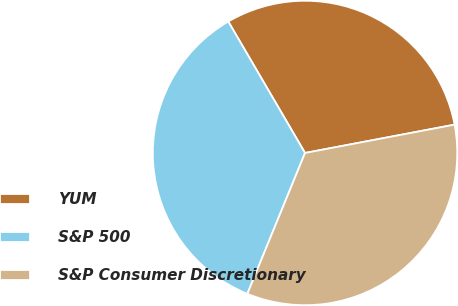Convert chart. <chart><loc_0><loc_0><loc_500><loc_500><pie_chart><fcel>YUM<fcel>S&P 500<fcel>S&P Consumer Discretionary<nl><fcel>30.43%<fcel>35.4%<fcel>34.16%<nl></chart> 